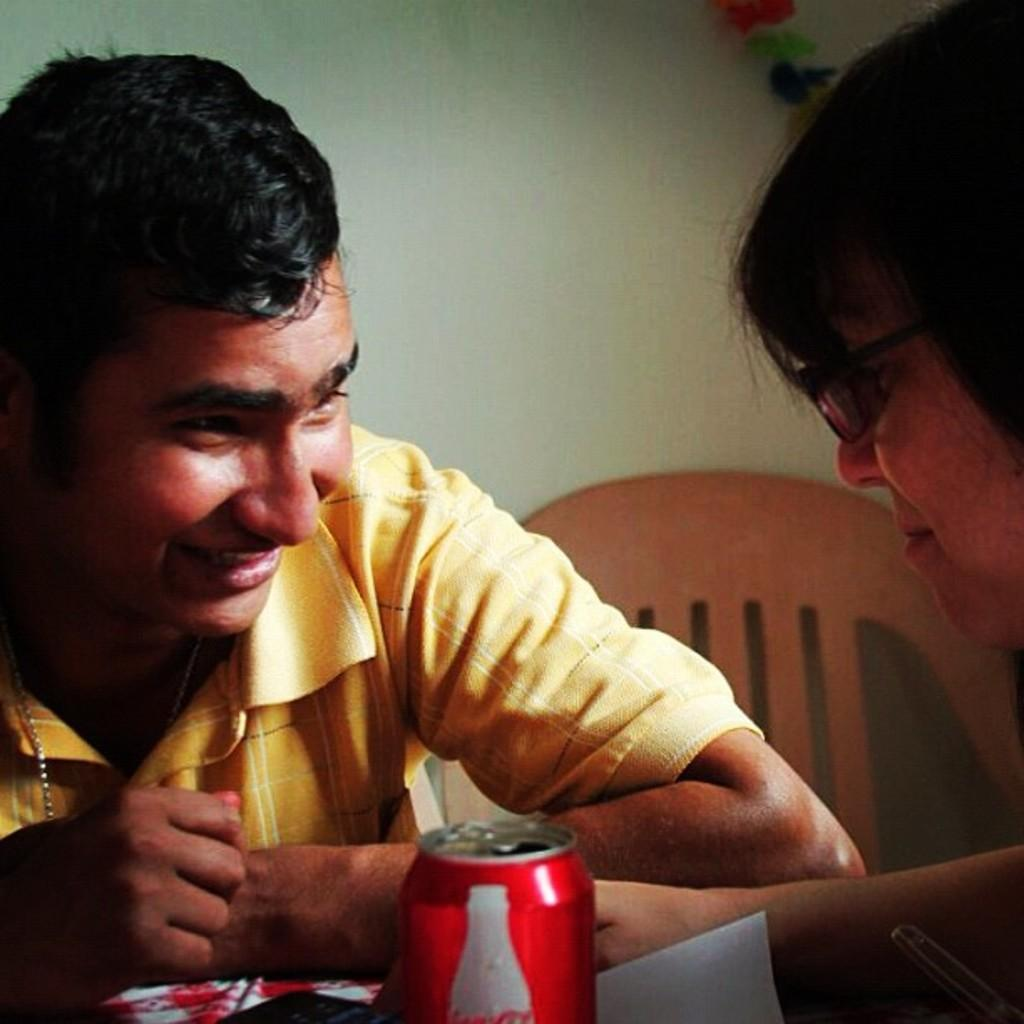How many people are in the image? There are two people in the image. What are the two people doing in the image? The two people are sitting. Where are the two people sitting? They are sitting in front of a table. What can be seen on the table in the image? There is a tin on the table. Is there any furniture visible beside the table? Yes, there is a chair to the side of the table. What type of property is being discussed by the two people in the image? There is no indication in the image that the two people are discussing any property. 